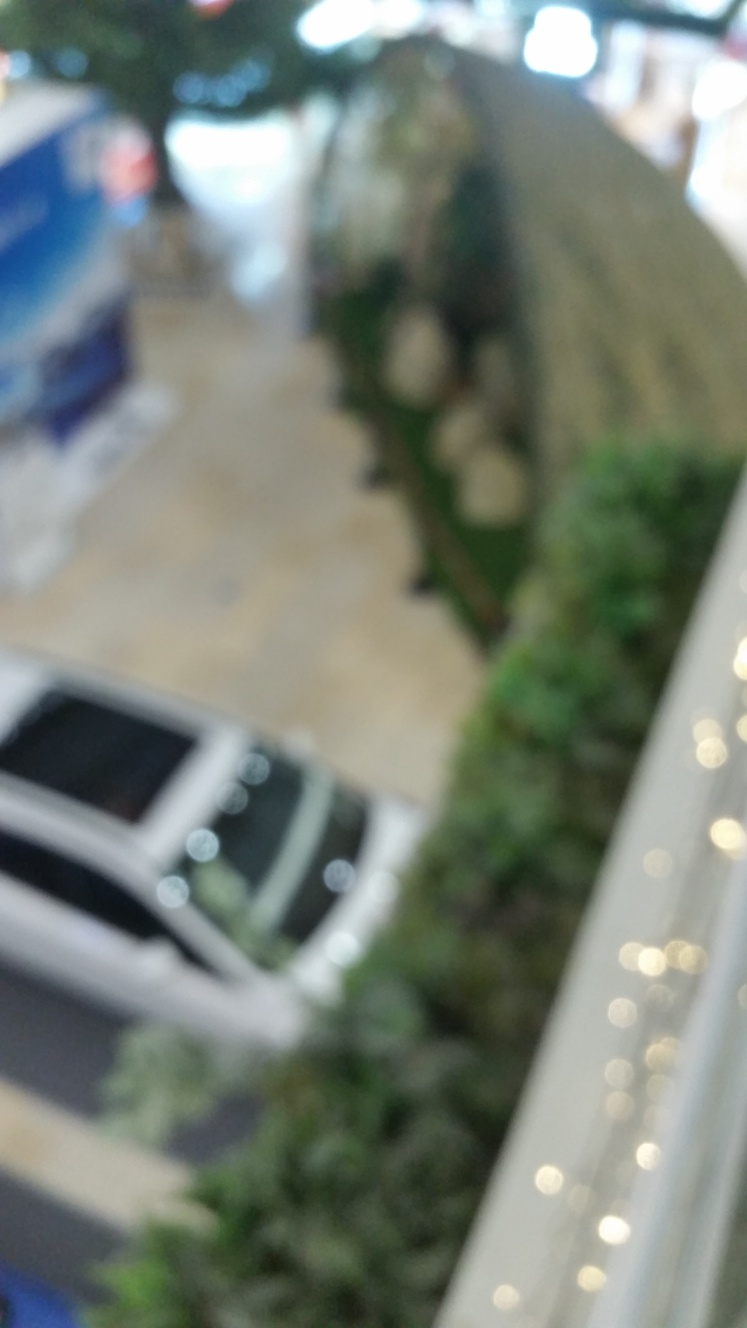Are there any quality issues with this image? Yes, the primary quality issue with this image is that it's significantly out of focus, which obscures the details of the scene. It appears to be taken from an elevated perspective, likely of an interior space such as a shopping mall or an atrium, but the lack of clarity makes it difficult to discern specific elements or activities within the space. 